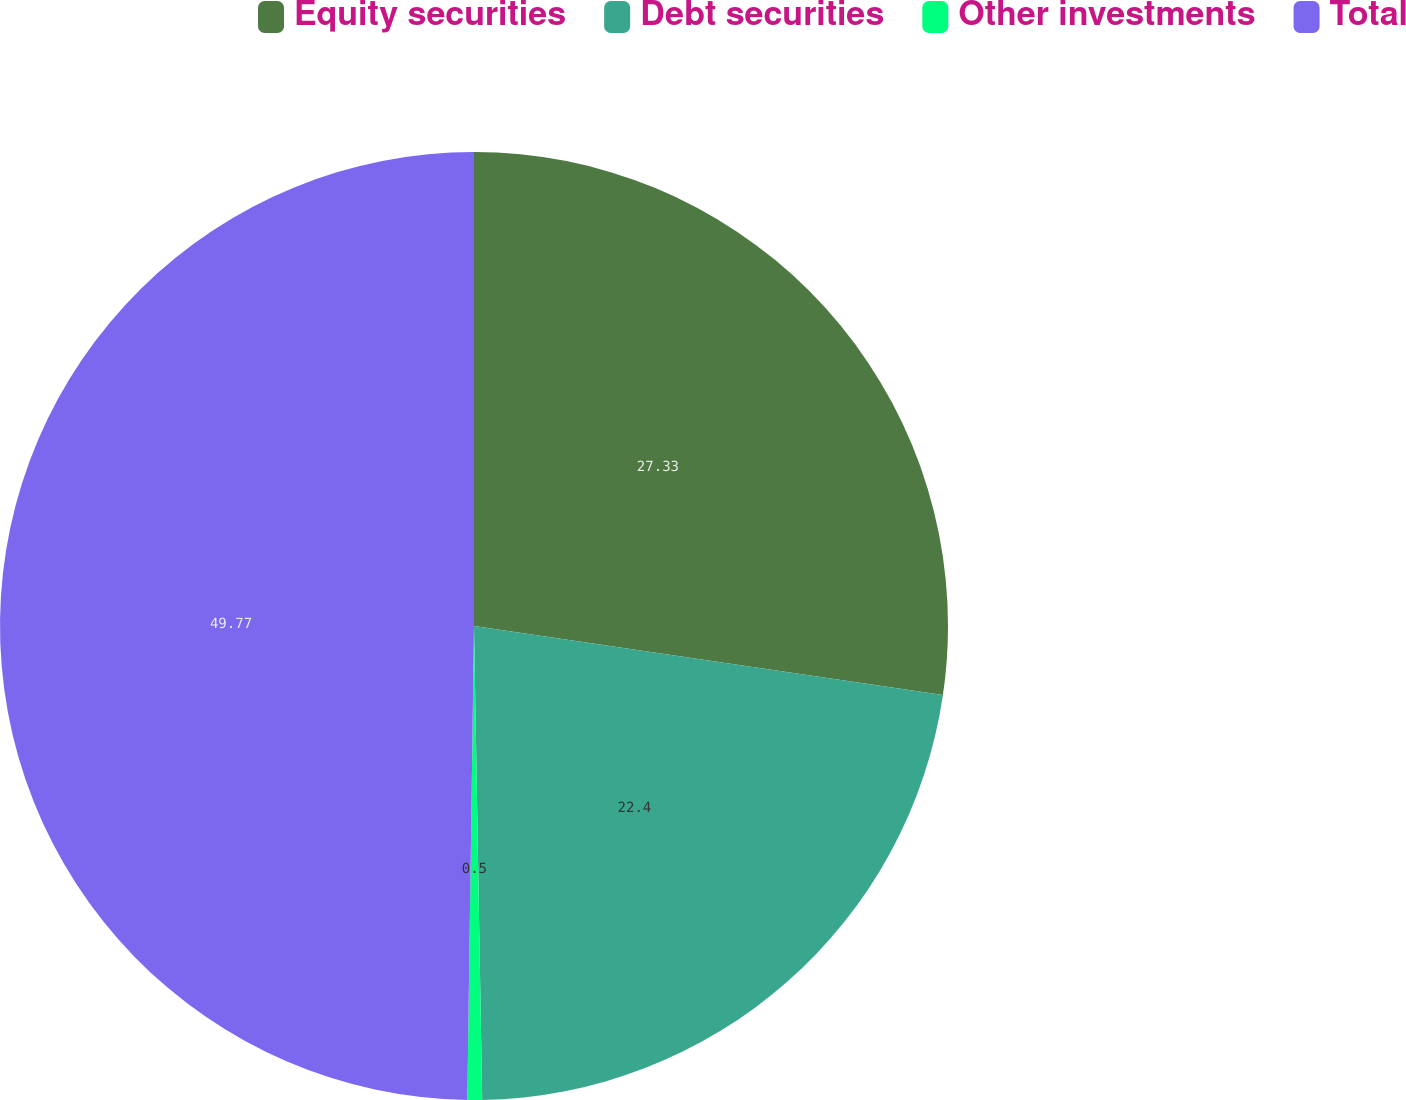Convert chart. <chart><loc_0><loc_0><loc_500><loc_500><pie_chart><fcel>Equity securities<fcel>Debt securities<fcel>Other investments<fcel>Total<nl><fcel>27.33%<fcel>22.4%<fcel>0.5%<fcel>49.78%<nl></chart> 